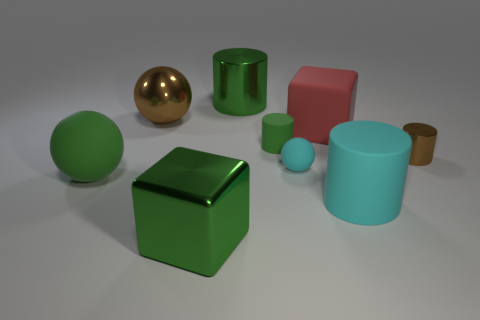There is a big matte thing left of the large red thing; does it have the same color as the big shiny block?
Ensure brevity in your answer.  Yes. The green object that is the same shape as the large brown thing is what size?
Provide a short and direct response. Large. There is another cylinder that is the same color as the large metallic cylinder; what is its size?
Make the answer very short. Small. Are there any green metallic cubes?
Your response must be concise. Yes. What is the color of the matte cylinder that is the same size as the brown metallic cylinder?
Make the answer very short. Green. How many brown objects have the same shape as the large cyan matte thing?
Offer a terse response. 1. Are the small cylinder that is on the right side of the cyan cylinder and the green block made of the same material?
Your answer should be compact. Yes. What number of cylinders are either large green matte objects or green metallic things?
Your answer should be very brief. 1. What shape is the large green object that is on the right side of the green block on the left side of the big metal thing to the right of the green cube?
Your response must be concise. Cylinder. What shape is the large thing that is the same color as the tiny metal cylinder?
Provide a short and direct response. Sphere. 